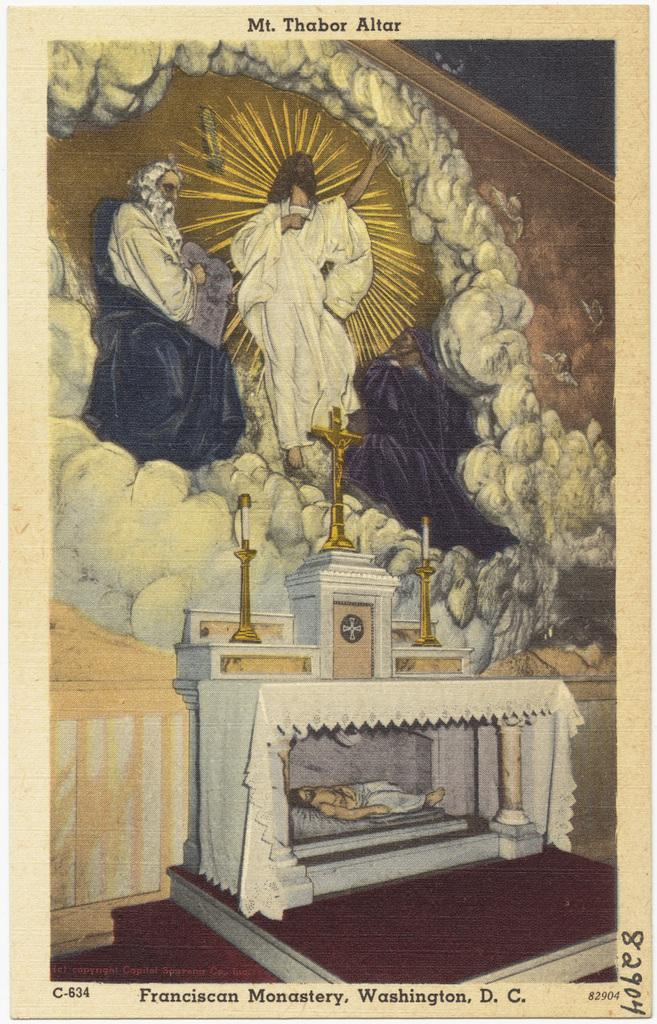What type of art is depicted in the image? The image is a paper cutting. What can be seen in the picture? There are men in the picture. Where is text located in the image? There is text at the bottom and top of the picture. How many cats can be seen playing on the coast in the image? There are no cats or coast visible in the image; it is a paper cutting featuring men and text. 